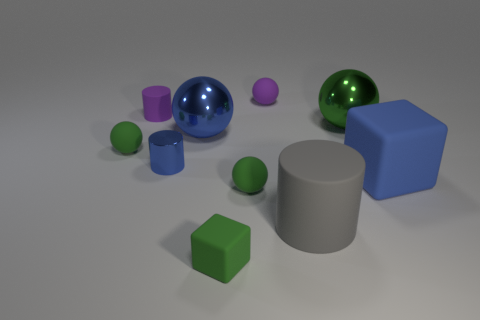There is a thing that is both on the right side of the tiny matte cube and behind the large green ball; what is its shape?
Keep it short and to the point. Sphere. What number of green things have the same material as the big green sphere?
Offer a terse response. 0. What number of tiny blue objects are behind the blue thing that is to the left of the blue shiny sphere?
Provide a short and direct response. 0. What shape is the tiny green matte object that is to the left of the large shiny thing on the left side of the small purple object on the right side of the blue sphere?
Your response must be concise. Sphere. The metal ball that is the same color as the small shiny cylinder is what size?
Make the answer very short. Large. How many things are either small purple metallic cylinders or purple rubber cylinders?
Ensure brevity in your answer.  1. There is another cylinder that is the same size as the purple rubber cylinder; what color is it?
Make the answer very short. Blue. Do the tiny blue thing and the purple object to the left of the big blue ball have the same shape?
Your answer should be compact. Yes. What number of things are large matte things that are to the right of the gray object or matte cylinders that are behind the large gray rubber object?
Give a very brief answer. 2. There is a tiny object that is the same color as the big block; what is its shape?
Your answer should be compact. Cylinder. 